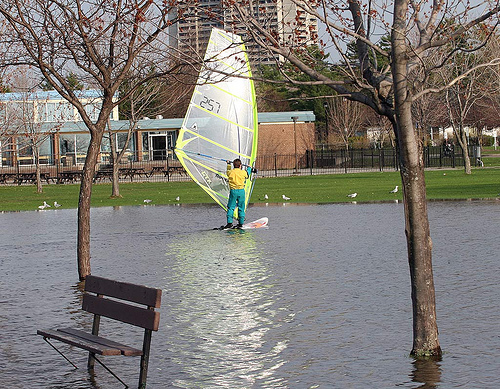Please extract the text content from this image. 257 